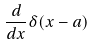Convert formula to latex. <formula><loc_0><loc_0><loc_500><loc_500>\frac { d } { d x } \delta ( x - a )</formula> 